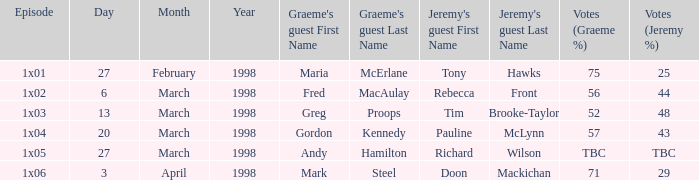What is Graeme's Guest, when Episode is "1x03"? Greg Proops. 